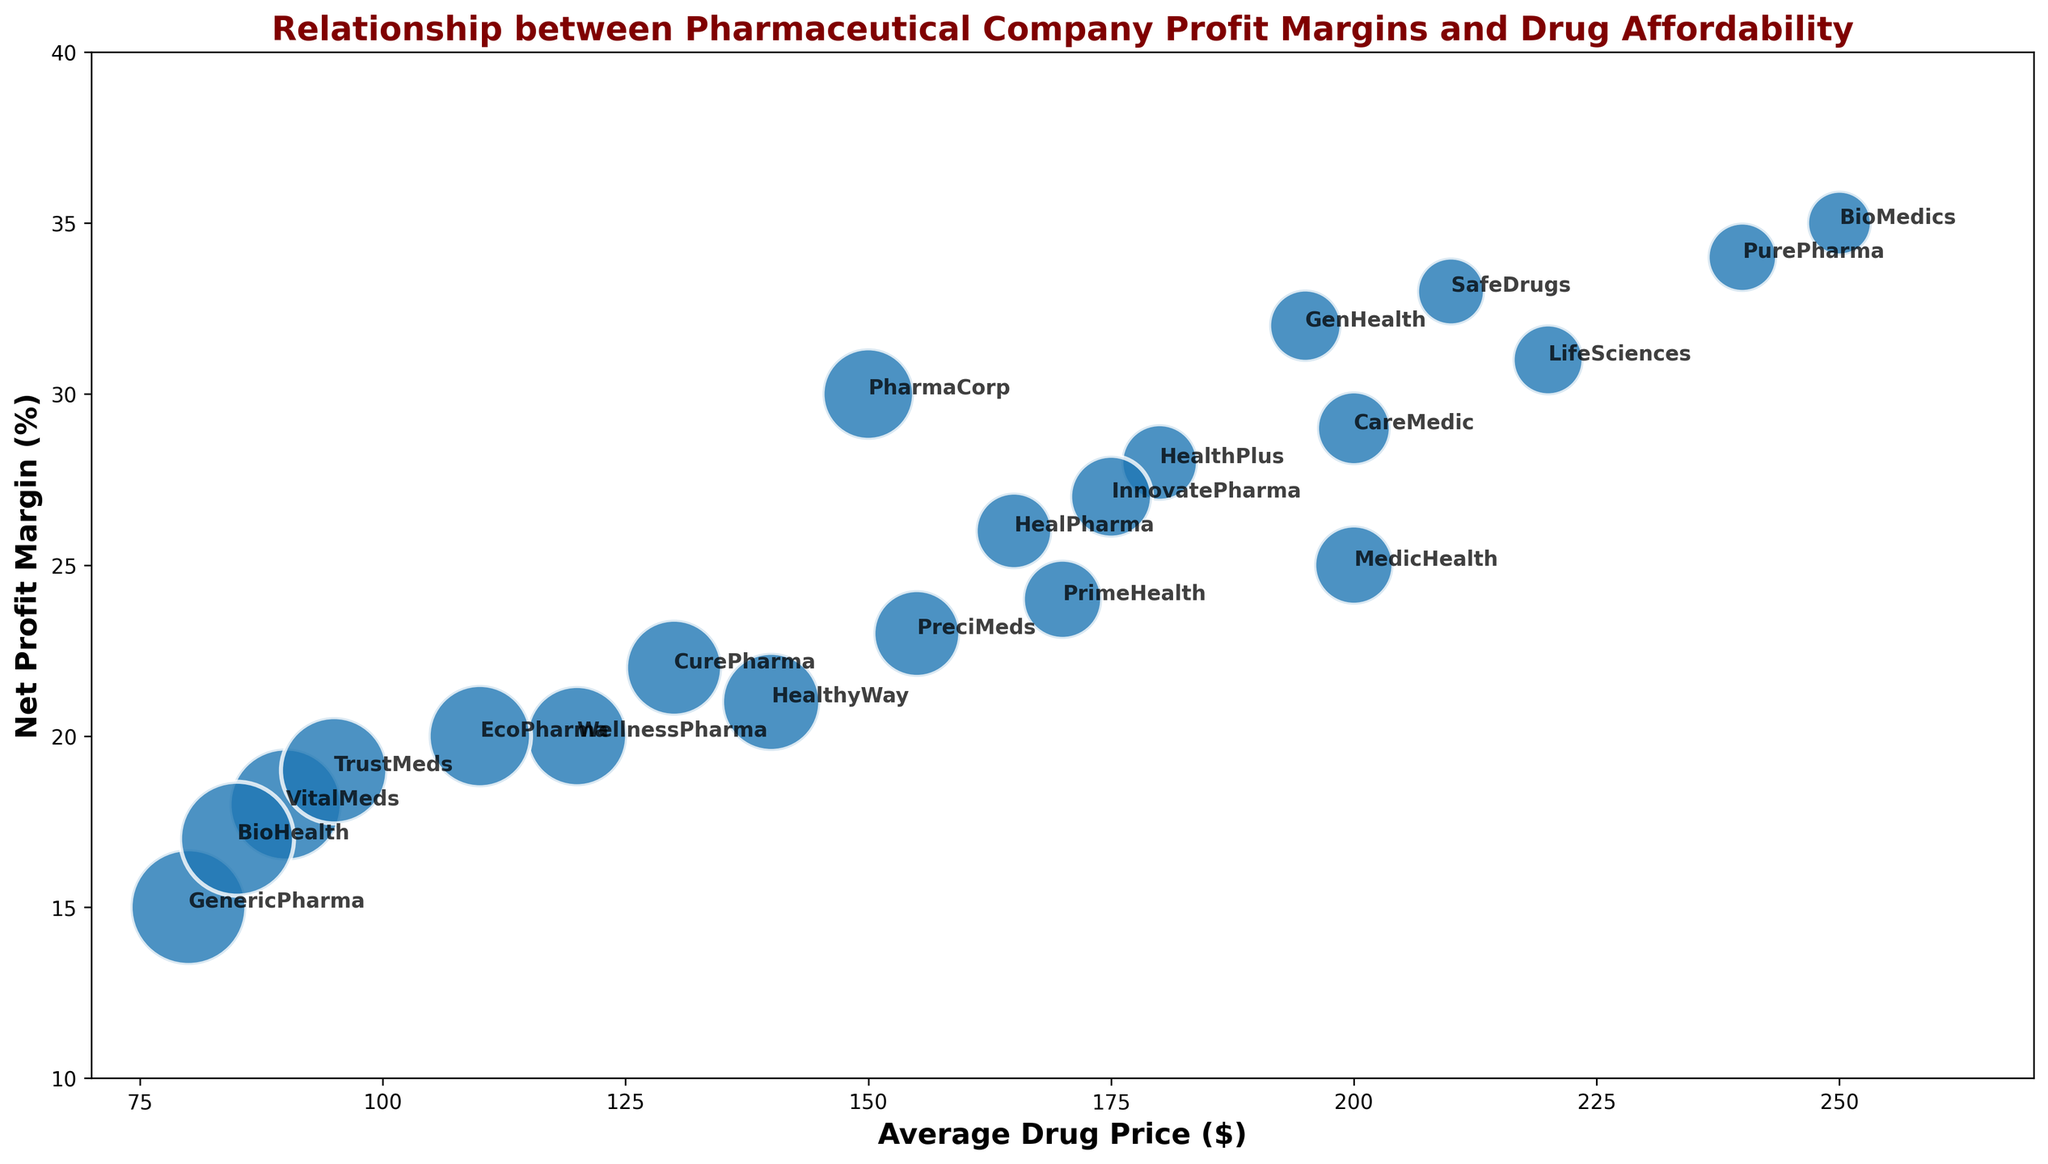Which company has the highest net profit margin and what is their average drug price? By looking at the topmost bubble, we can see that BioMedics has the highest net profit margin of 35%, with an average drug price of $250.
Answer: BioMedics, $250 Which company has the lowest average drug price and how many units did they sell? By identifying the bubble closest to the left, we see that GenericPharma has the lowest average drug price at $80 and sold 32,000 units.
Answer: GenericPharma, 32,000 units Which companies have a net profit margin of 30% or more? Observing the bubbles above the 30% mark on the y-axis, the companies are PharmaCorp, BioMedics, LifeSciences, SafeDrugs, PurePharma, and GenHealth.
Answer: PharmaCorp, BioMedics, LifeSciences, SafeDrugs, PurePharma, GenHealth What is the combined average drug price for InnovatePharma and CareMedic? InnovatePharma has an average drug price of $175 and CareMedic has an average drug price of $200. Adding these together and dividing by 2 gives ($175 + $200) / 2 = $187.50.
Answer: $187.50 Which company sells the most units at the lowest profit margin? The largest bubble at the lowest vertical position indicates TrustMeds, with a net profit margin of 19% and selling 27,000 units.
Answer: TrustMeds What is the average net profit margin for CurePharma and HealPharma? CurePharma has a net profit margin of 22% and HealPharma has 26%. Adding these together and dividing by 2 gives (22 + 26) / 2 = 24%.
Answer: 24% Which company has a higher average drug price: CuraPharma or HealthyWay, and by how much? By comparing the bubble positions horizontally, CuraPharma's average price is $130 and HealthyWay's is $140. The difference is $140 - $130 = $10.
Answer: HealthyWay, $10 Which company has a higher net profit margin: PrimeHealth or PreciMeds? Comparing vertically, PrimeHealth has a net profit margin of 24% while PreciMeds has 23%.
Answer: PrimeHealth What is the difference in units sold between the company with the highest average drug price and the company with the lowest average drug price? The highest average drug price is BioMedics at $250 (10,000 units) and the lowest is GenericPharma at $80 (32,000 units). The difference is 32,000 - 10,000 = 22,000 units.
Answer: 22,000 units How does the net profit margin of VitalMeds compare with that of TrustMeds? On the vertical axis, we can see that VitalMeds has an 18% net profit margin while TrustMeds has 19%. Thus, TrustMeds has a higher margin by 1%.
Answer: TrustMeds has a higher margin, by 1% 